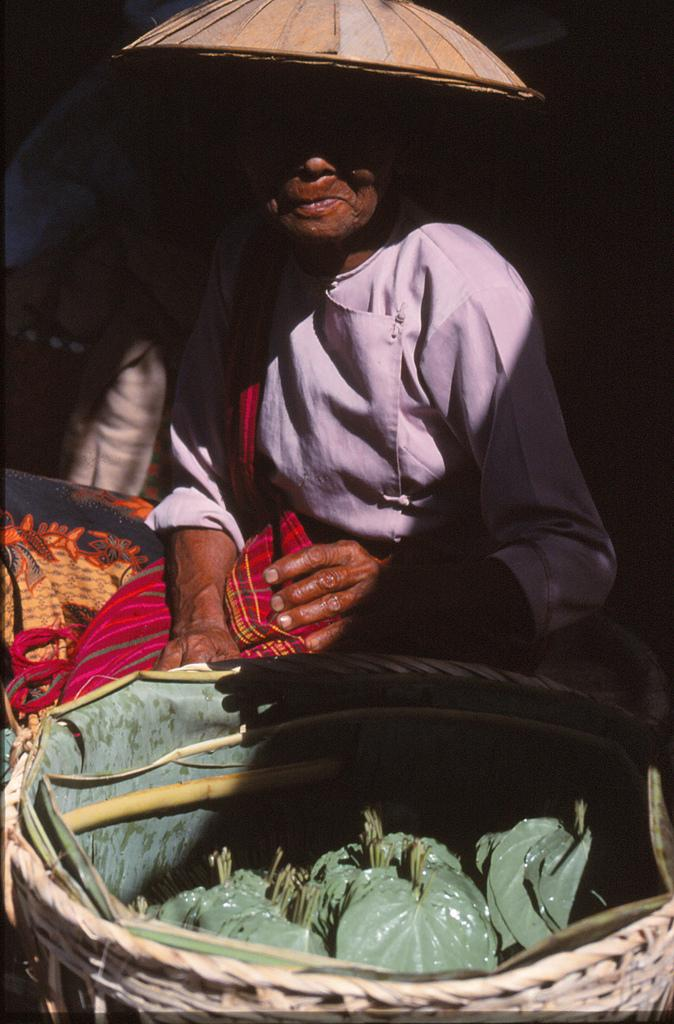Who is the main subject in the image? There is a woman sitting in the center of the image. What is the woman wearing on her head? The woman is wearing an umbrella hat. What is in front of the woman? There is a basket in front of the woman. What is inside the basket? The basket contains leaves. What type of slope can be seen in the background of the image? There is no slope visible in the background of the image. 